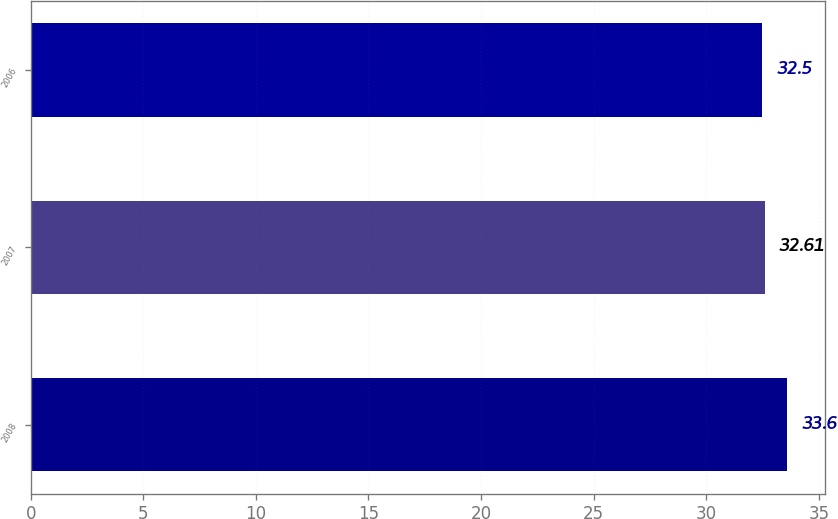Convert chart. <chart><loc_0><loc_0><loc_500><loc_500><bar_chart><fcel>2008<fcel>2007<fcel>2006<nl><fcel>33.6<fcel>32.61<fcel>32.5<nl></chart> 